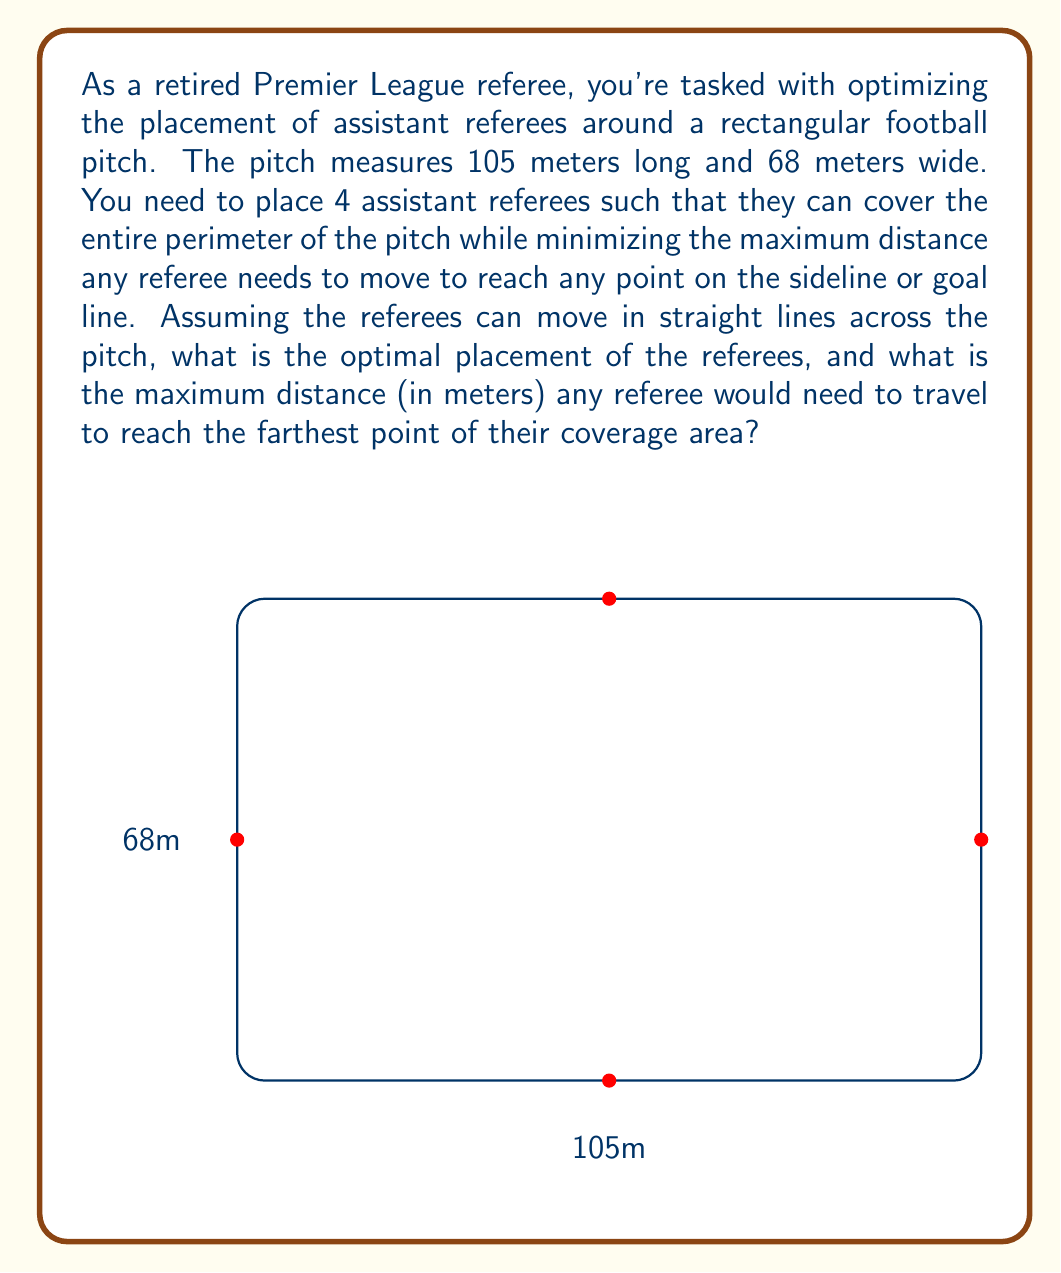Give your solution to this math problem. Let's approach this step-by-step:

1) The optimal placement of the referees would be at the midpoints of each side of the rectangular pitch. This ensures that each referee is responsible for half of the side they're on.

2) Given the dimensions of the pitch:
   - Two referees will be placed at (0, 34) and (105, 34) on the long sides
   - Two referees will be placed at (52.5, 0) and (52.5, 68) on the short sides

3) Now, we need to calculate the maximum distance a referee might need to travel. This would be from their position to the corner of the pitch farthest from them.

4) Due to symmetry, we can consider any of the referees. Let's choose the referee at (0, 34).

5) The farthest point for this referee would be the opposite corner at (105, 68) or (105, 0).

6) We can calculate this distance using the Pythagorean theorem:

   $$d = \sqrt{(105-0)^2 + (68-34)^2} = \sqrt{105^2 + 34^2}$$

7) Simplifying:
   $$d = \sqrt{11025 + 1156} = \sqrt{12181} \approx 110.37$$

Therefore, the maximum distance any referee would need to travel is approximately 110.37 meters.
Answer: 110.37 meters 